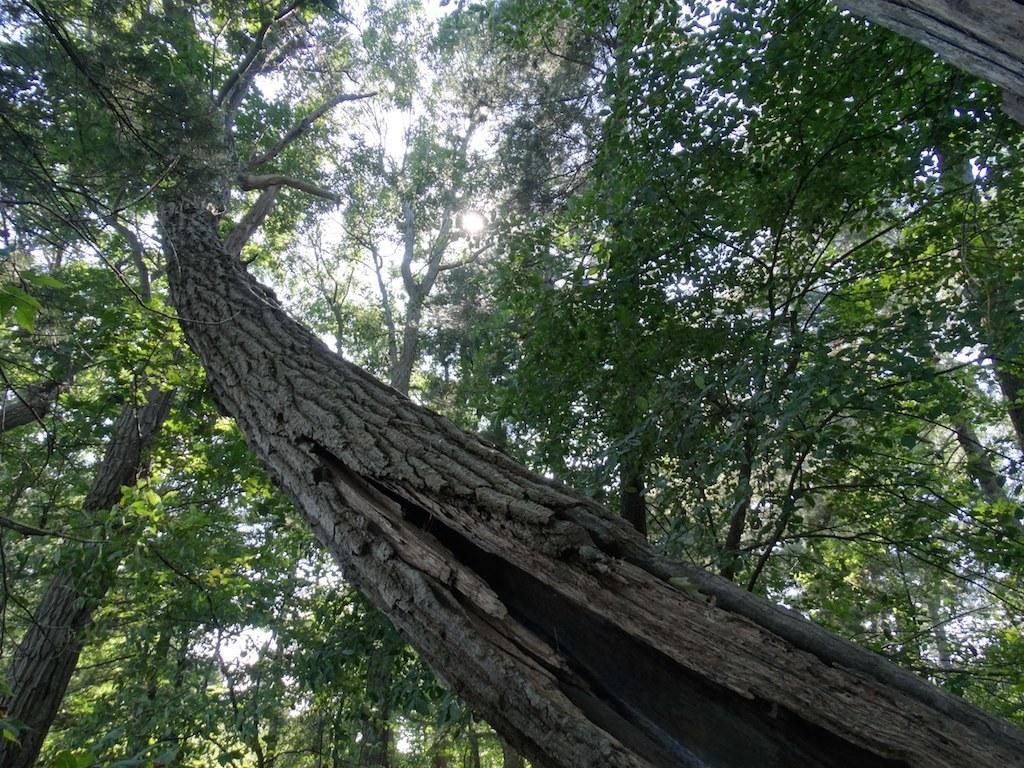Please provide a concise description of this image. In this image we can see trees and sky. 